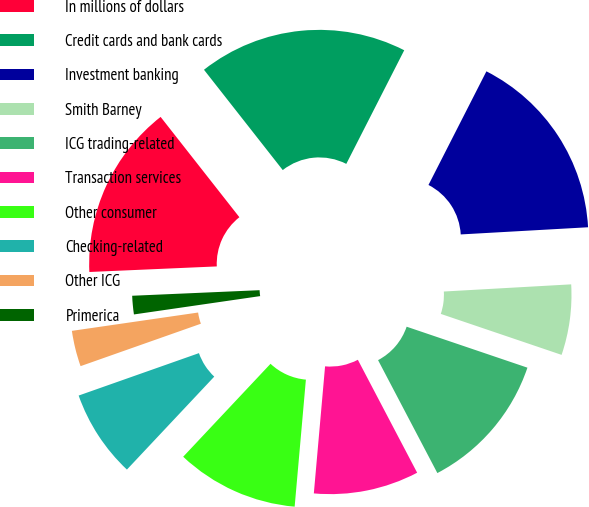Convert chart. <chart><loc_0><loc_0><loc_500><loc_500><pie_chart><fcel>In millions of dollars<fcel>Credit cards and bank cards<fcel>Investment banking<fcel>Smith Barney<fcel>ICG trading-related<fcel>Transaction services<fcel>Other consumer<fcel>Checking-related<fcel>Other ICG<fcel>Primerica<nl><fcel>15.1%<fcel>18.1%<fcel>16.6%<fcel>6.1%<fcel>12.1%<fcel>9.1%<fcel>10.6%<fcel>7.6%<fcel>3.1%<fcel>1.6%<nl></chart> 